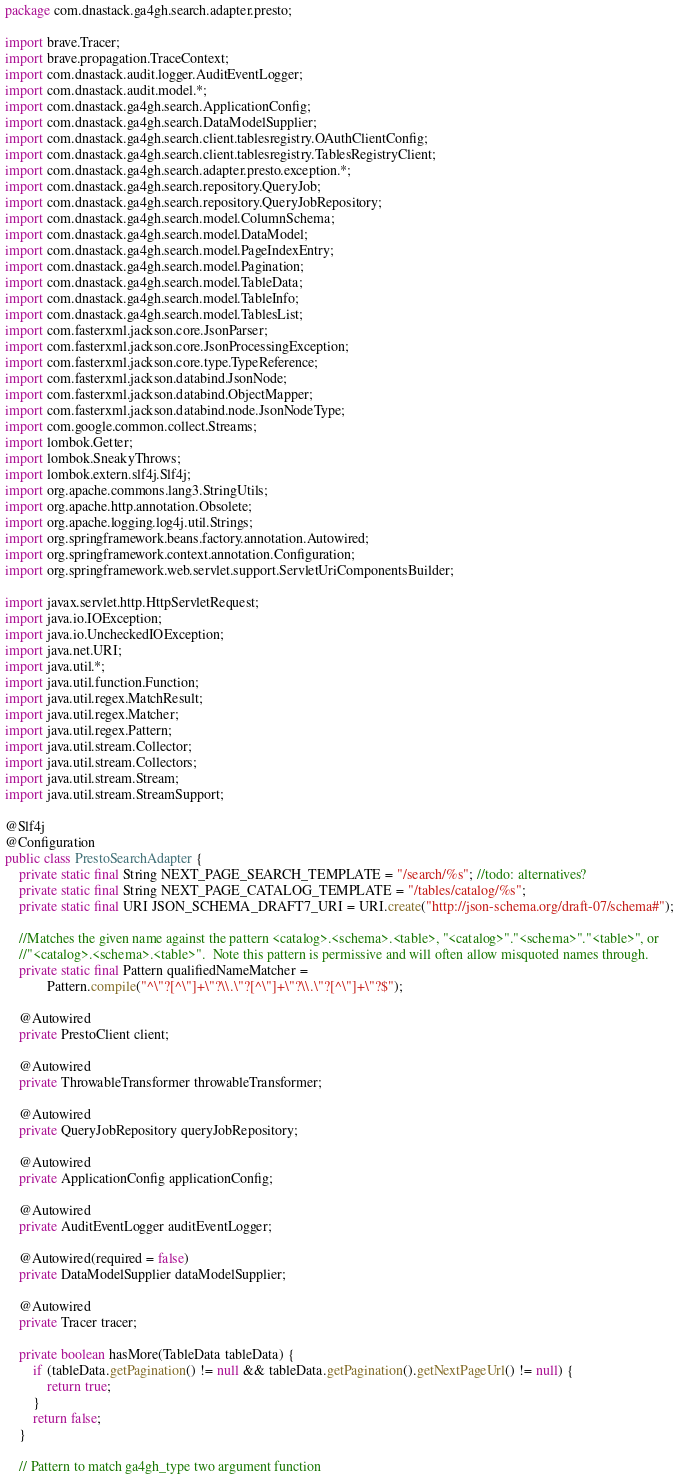<code> <loc_0><loc_0><loc_500><loc_500><_Java_>package com.dnastack.ga4gh.search.adapter.presto;

import brave.Tracer;
import brave.propagation.TraceContext;
import com.dnastack.audit.logger.AuditEventLogger;
import com.dnastack.audit.model.*;
import com.dnastack.ga4gh.search.ApplicationConfig;
import com.dnastack.ga4gh.search.DataModelSupplier;
import com.dnastack.ga4gh.search.client.tablesregistry.OAuthClientConfig;
import com.dnastack.ga4gh.search.client.tablesregistry.TablesRegistryClient;
import com.dnastack.ga4gh.search.adapter.presto.exception.*;
import com.dnastack.ga4gh.search.repository.QueryJob;
import com.dnastack.ga4gh.search.repository.QueryJobRepository;
import com.dnastack.ga4gh.search.model.ColumnSchema;
import com.dnastack.ga4gh.search.model.DataModel;
import com.dnastack.ga4gh.search.model.PageIndexEntry;
import com.dnastack.ga4gh.search.model.Pagination;
import com.dnastack.ga4gh.search.model.TableData;
import com.dnastack.ga4gh.search.model.TableInfo;
import com.dnastack.ga4gh.search.model.TablesList;
import com.fasterxml.jackson.core.JsonParser;
import com.fasterxml.jackson.core.JsonProcessingException;
import com.fasterxml.jackson.core.type.TypeReference;
import com.fasterxml.jackson.databind.JsonNode;
import com.fasterxml.jackson.databind.ObjectMapper;
import com.fasterxml.jackson.databind.node.JsonNodeType;
import com.google.common.collect.Streams;
import lombok.Getter;
import lombok.SneakyThrows;
import lombok.extern.slf4j.Slf4j;
import org.apache.commons.lang3.StringUtils;
import org.apache.http.annotation.Obsolete;
import org.apache.logging.log4j.util.Strings;
import org.springframework.beans.factory.annotation.Autowired;
import org.springframework.context.annotation.Configuration;
import org.springframework.web.servlet.support.ServletUriComponentsBuilder;

import javax.servlet.http.HttpServletRequest;
import java.io.IOException;
import java.io.UncheckedIOException;
import java.net.URI;
import java.util.*;
import java.util.function.Function;
import java.util.regex.MatchResult;
import java.util.regex.Matcher;
import java.util.regex.Pattern;
import java.util.stream.Collector;
import java.util.stream.Collectors;
import java.util.stream.Stream;
import java.util.stream.StreamSupport;

@Slf4j
@Configuration
public class PrestoSearchAdapter {
    private static final String NEXT_PAGE_SEARCH_TEMPLATE = "/search/%s"; //todo: alternatives?
    private static final String NEXT_PAGE_CATALOG_TEMPLATE = "/tables/catalog/%s";
    private static final URI JSON_SCHEMA_DRAFT7_URI = URI.create("http://json-schema.org/draft-07/schema#");

    //Matches the given name against the pattern <catalog>.<schema>.<table>, "<catalog>"."<schema>"."<table>", or
    //"<catalog>.<schema>.<table>".  Note this pattern is permissive and will often allow misquoted names through.
    private static final Pattern qualifiedNameMatcher =
            Pattern.compile("^\"?[^\"]+\"?\\.\"?[^\"]+\"?\\.\"?[^\"]+\"?$");

    @Autowired
    private PrestoClient client;

    @Autowired
    private ThrowableTransformer throwableTransformer;

    @Autowired
    private QueryJobRepository queryJobRepository;

    @Autowired
    private ApplicationConfig applicationConfig;

    @Autowired
    private AuditEventLogger auditEventLogger;

    @Autowired(required = false)
    private DataModelSupplier dataModelSupplier;

    @Autowired
    private Tracer tracer;

    private boolean hasMore(TableData tableData) {
        if (tableData.getPagination() != null && tableData.getPagination().getNextPageUrl() != null) {
            return true;
        }
        return false;
    }

    // Pattern to match ga4gh_type two argument function</code> 